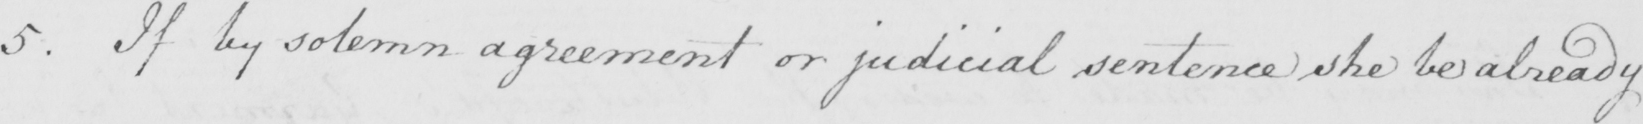Transcribe the text shown in this historical manuscript line. 5 . If by solemn agreement or judicial sentence she be already 